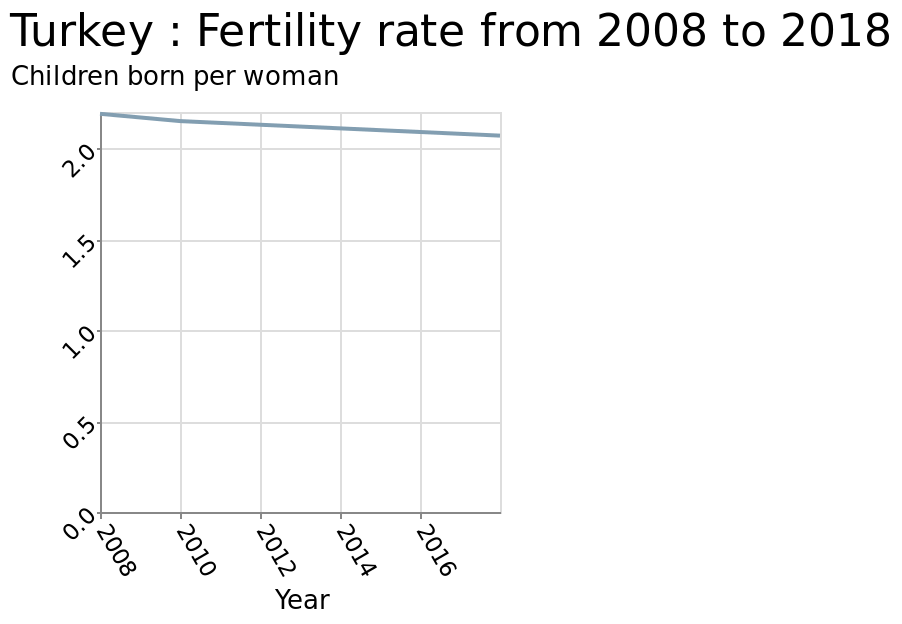<image>
Has the fertility rate increased or decreased since 2008? The fertility rate has decreased since 2008. 